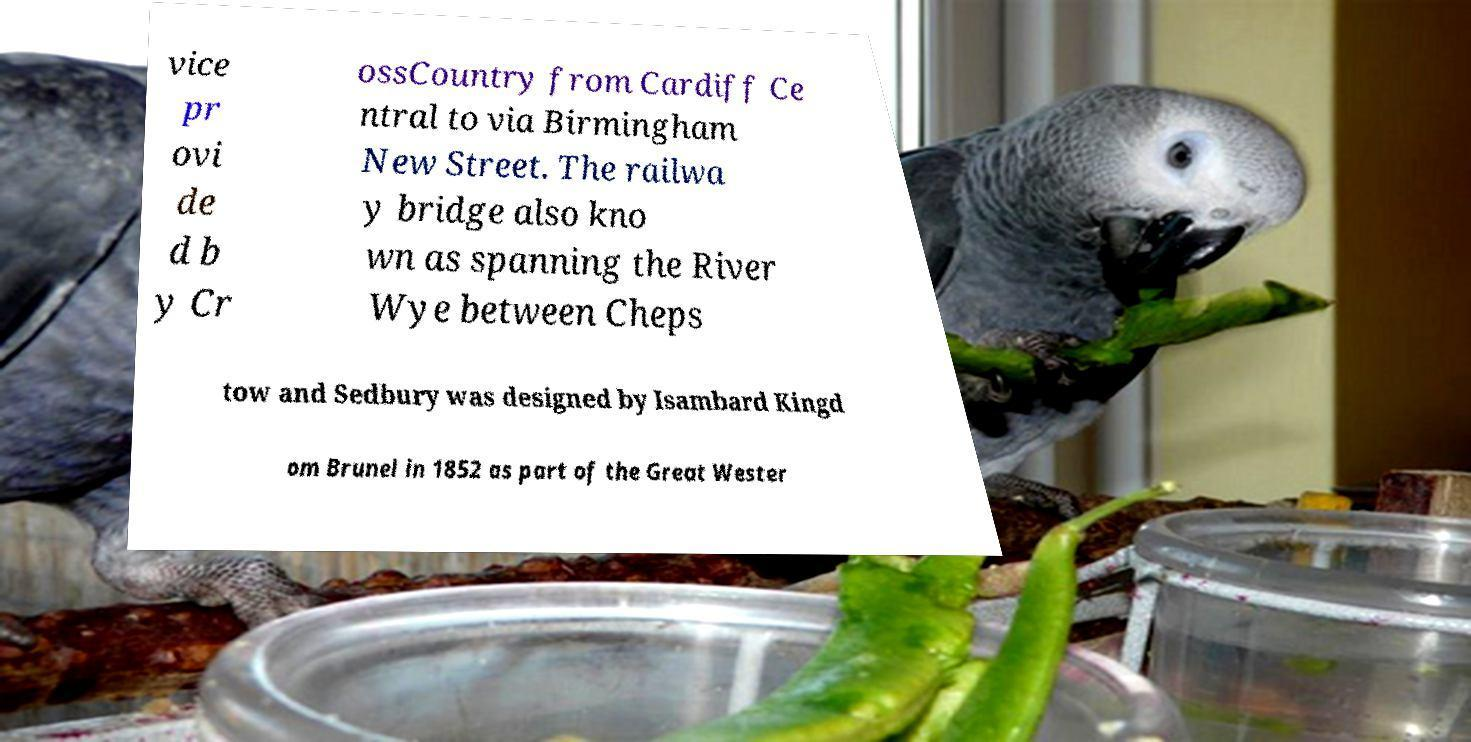Can you accurately transcribe the text from the provided image for me? vice pr ovi de d b y Cr ossCountry from Cardiff Ce ntral to via Birmingham New Street. The railwa y bridge also kno wn as spanning the River Wye between Cheps tow and Sedbury was designed by Isambard Kingd om Brunel in 1852 as part of the Great Wester 